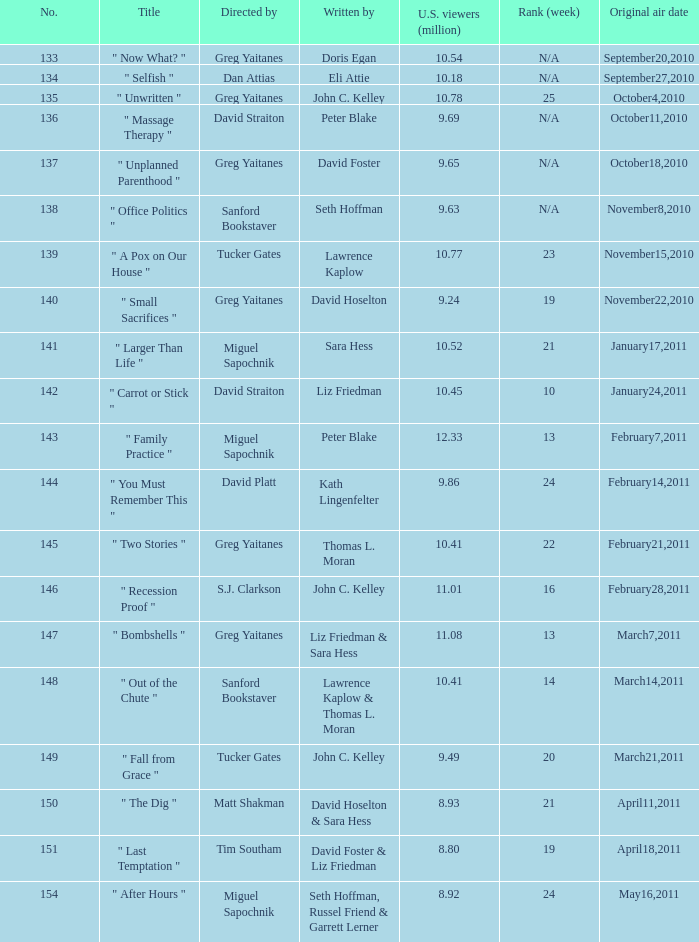Where did the episode rank that was written by thomas l. moran? 22.0. 